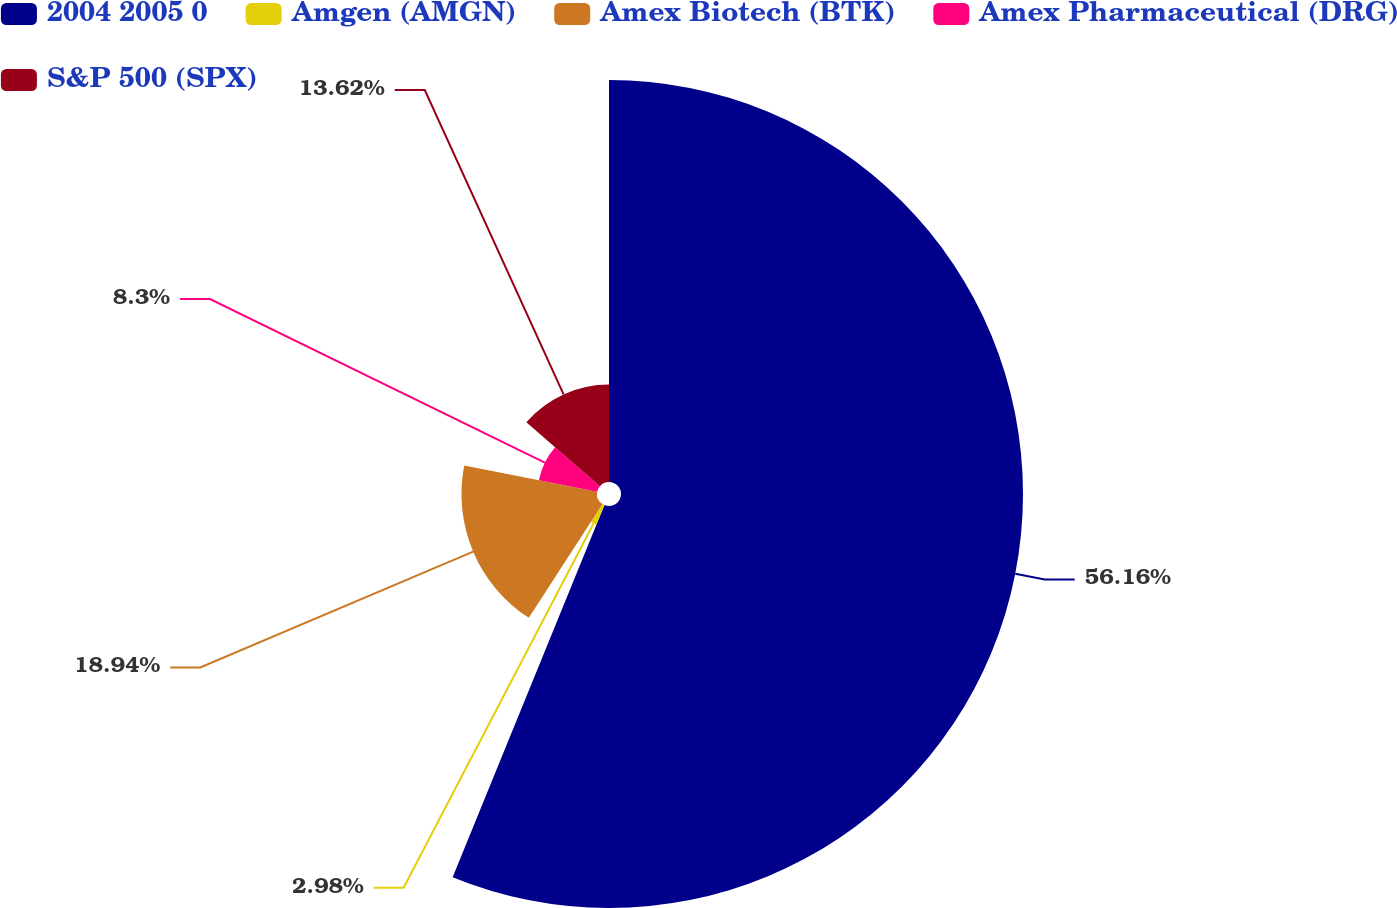<chart> <loc_0><loc_0><loc_500><loc_500><pie_chart><fcel>2004 2005 0<fcel>Amgen (AMGN)<fcel>Amex Biotech (BTK)<fcel>Amex Pharmaceutical (DRG)<fcel>S&P 500 (SPX)<nl><fcel>56.17%<fcel>2.98%<fcel>18.94%<fcel>8.3%<fcel>13.62%<nl></chart> 